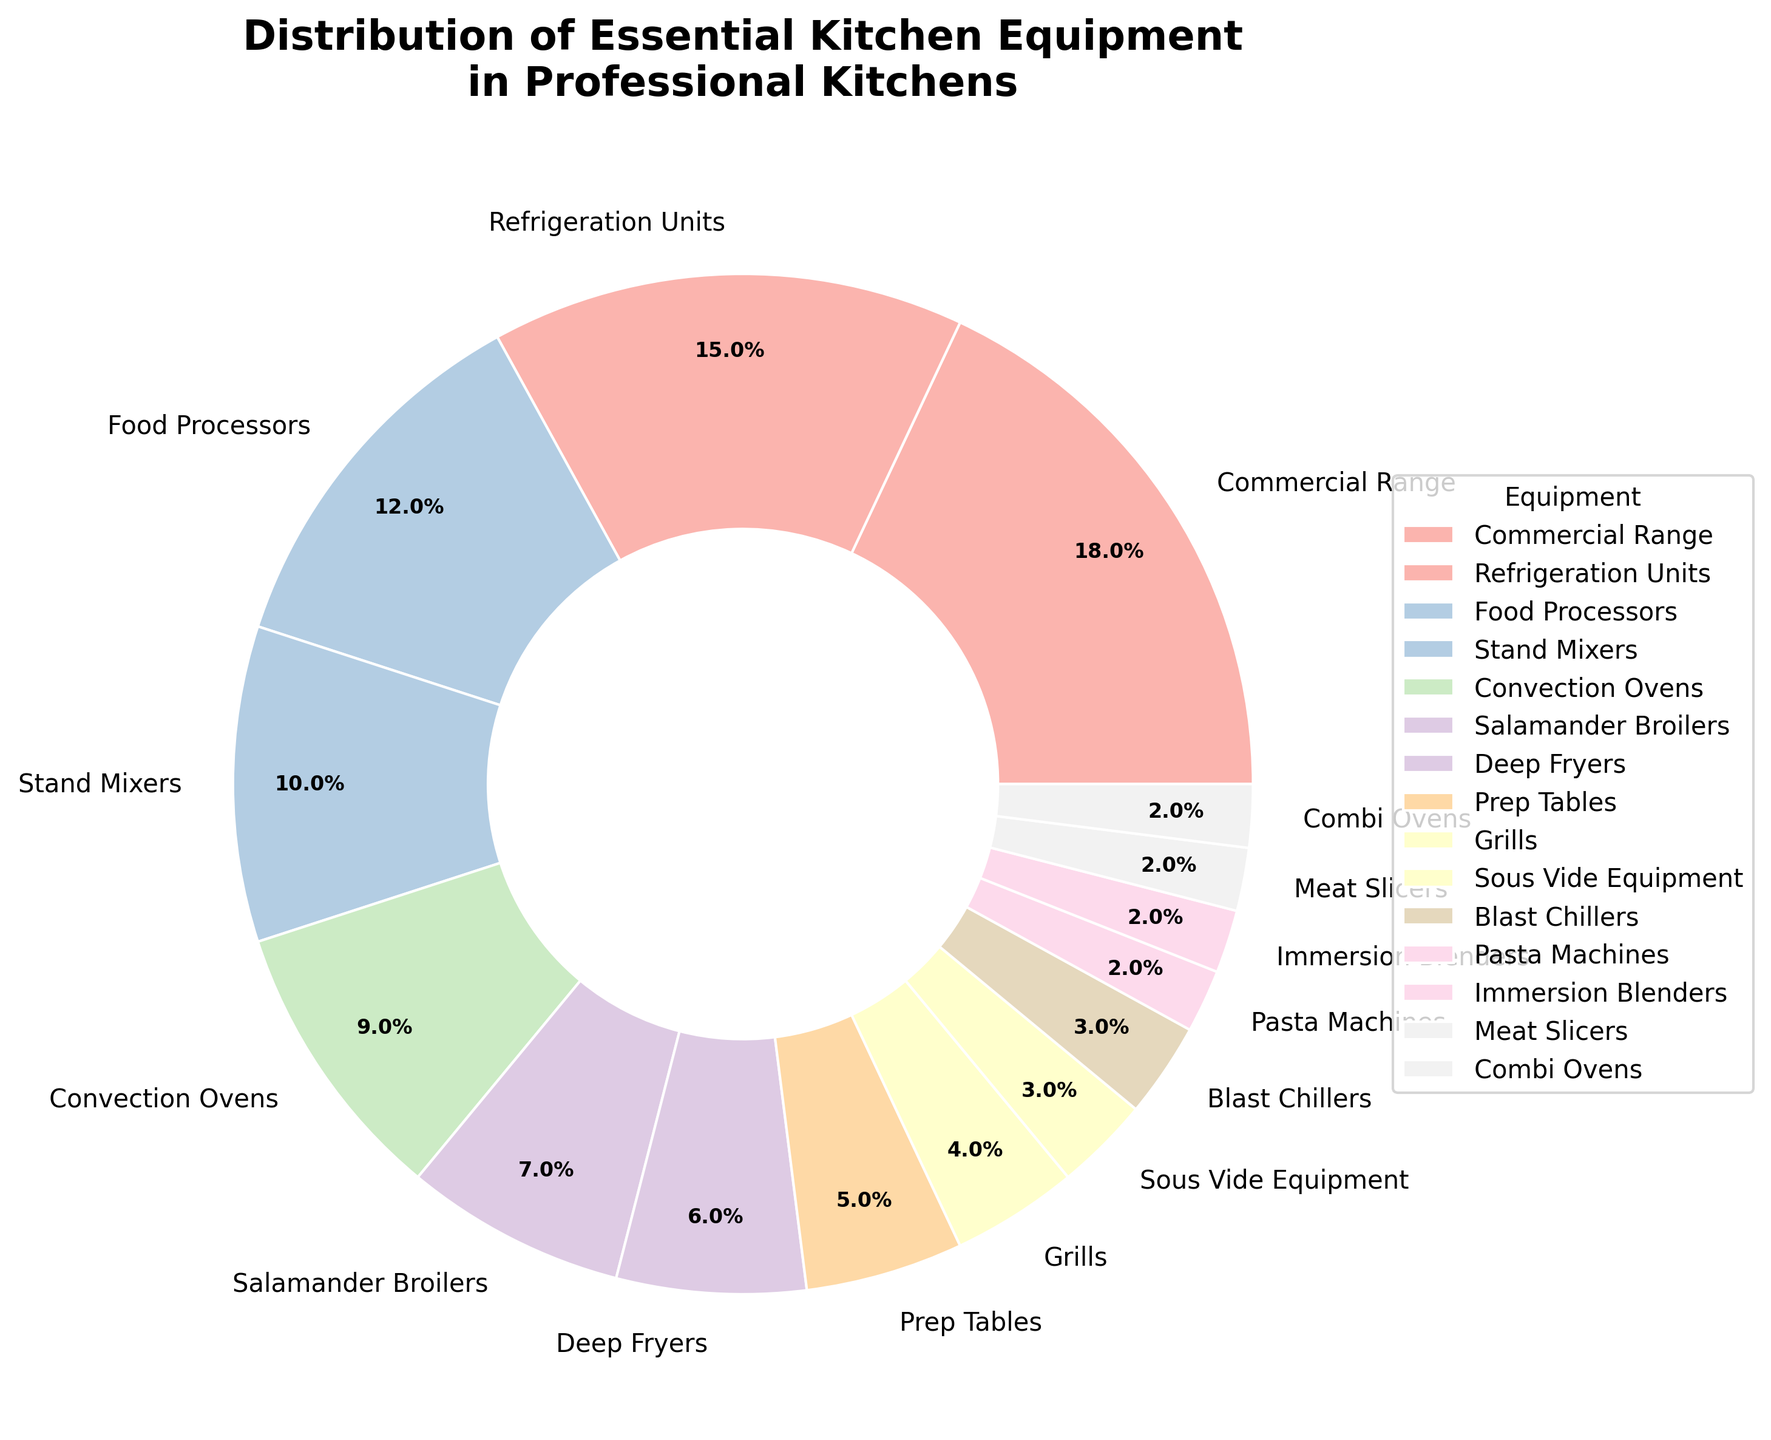Which piece of equipment has the highest percentage? Look at the pie chart and identify the segment with the largest slice. The "Commercial Range" has the largest percentage allocated.
Answer: Commercial Range Which equipment type has a lower percentage: "Food Processors" or "Stand Mixers"? Compare the size of the slices labeled "Food Processors" and "Stand Mixers." The "Stand Mixers" slice is smaller.
Answer: Stand Mixers What is the combined percentage of "Refrigeration Units" and "Blast Chillers"? Add the percentages of "Refrigeration Units" (15%) and "Blast Chillers" (3%) to get the total combined percentage. 15 + 3 = 18%.
Answer: 18% Between "Deep Fryers" and "Prep Tables," which equipment has a higher percentage? Compare the size of the slices for "Deep Fryers" and "Prep Tables." The "Deep Fryers" slice is larger.
Answer: Deep Fryers What is the total percentage of equipment types with exactly 2%? Sum the percentages of all equipment types listed with exactly 2%, which are "Pasta Machines," "Immersion Blenders," "Meat Slicers," and "Combi Ovens." 2 + 2 + 2 + 2 = 8%.
Answer: 8% Which occupies more percentage, "Grills" or the combined total of "Sous Vide Equipment" and "Blast Chillers"? Compare the percentage of "Grills" (4%) with the combined percentage of "Sous Vide Equipment" (3%) and "Blast Chillers" (3%). 3 + 3 = 6%, which is greater than 4%.
Answer: Combined total of Sous Vide Equipment and Blast Chillers Is the percentage of "Salamander Broilers" closer to "Convection Ovens" or "Deep Fryers"? Compare the percentage of "Salamander Broilers" (7%) with "Convection Ovens" (9%) and "Deep Fryers" (6%). The difference between "Salamander Broilers" and "Deep Fryers" is 1%, and the difference with "Convection Ovens" is 2%. Therefore, it is closer to "Deep Fryers."
Answer: Deep Fryers How does the percentage of "Stand Mixers" compare to the average percentage of all listed equipment? First, calculate the average percentage by summing all individual percentages and dividing by the number of equipment types. The total sum of all percentages is 100%, with 15 equipment types, so the average is 100/15 ≈ 6.67%. Since "Stand Mixers" is at 10%, it is above the average.
Answer: Above average What percentage of professional kitchens do not include "Stand Mixers"? Since the percentage of kitchens with "Stand Mixers" is 10%, the percentage without "Stand Mixers" is 100% - 10% = 90%.
Answer: 90% What is the difference in percentage between the highest and lowest equipment types? The highest percentage is "Commercial Range" at 18%, and the lowest is shared by several equipment types, all at 2%. The difference is 18 - 2 = 16%.
Answer: 16% 